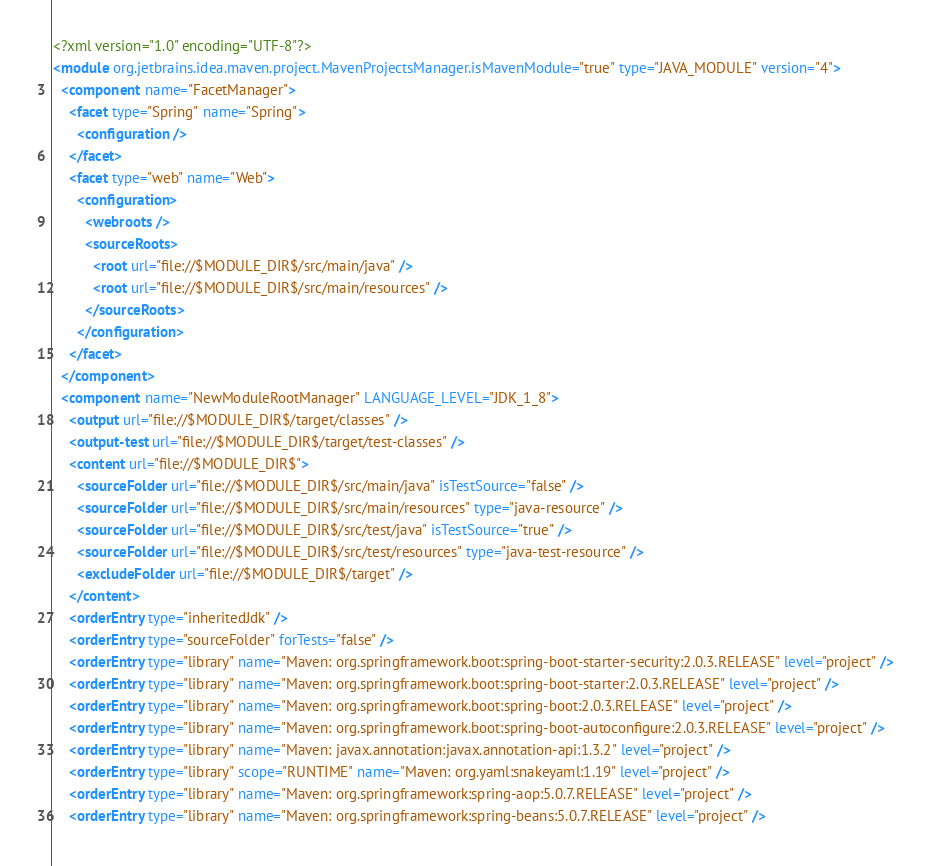Convert code to text. <code><loc_0><loc_0><loc_500><loc_500><_XML_><?xml version="1.0" encoding="UTF-8"?>
<module org.jetbrains.idea.maven.project.MavenProjectsManager.isMavenModule="true" type="JAVA_MODULE" version="4">
  <component name="FacetManager">
    <facet type="Spring" name="Spring">
      <configuration />
    </facet>
    <facet type="web" name="Web">
      <configuration>
        <webroots />
        <sourceRoots>
          <root url="file://$MODULE_DIR$/src/main/java" />
          <root url="file://$MODULE_DIR$/src/main/resources" />
        </sourceRoots>
      </configuration>
    </facet>
  </component>
  <component name="NewModuleRootManager" LANGUAGE_LEVEL="JDK_1_8">
    <output url="file://$MODULE_DIR$/target/classes" />
    <output-test url="file://$MODULE_DIR$/target/test-classes" />
    <content url="file://$MODULE_DIR$">
      <sourceFolder url="file://$MODULE_DIR$/src/main/java" isTestSource="false" />
      <sourceFolder url="file://$MODULE_DIR$/src/main/resources" type="java-resource" />
      <sourceFolder url="file://$MODULE_DIR$/src/test/java" isTestSource="true" />
      <sourceFolder url="file://$MODULE_DIR$/src/test/resources" type="java-test-resource" />
      <excludeFolder url="file://$MODULE_DIR$/target" />
    </content>
    <orderEntry type="inheritedJdk" />
    <orderEntry type="sourceFolder" forTests="false" />
    <orderEntry type="library" name="Maven: org.springframework.boot:spring-boot-starter-security:2.0.3.RELEASE" level="project" />
    <orderEntry type="library" name="Maven: org.springframework.boot:spring-boot-starter:2.0.3.RELEASE" level="project" />
    <orderEntry type="library" name="Maven: org.springframework.boot:spring-boot:2.0.3.RELEASE" level="project" />
    <orderEntry type="library" name="Maven: org.springframework.boot:spring-boot-autoconfigure:2.0.3.RELEASE" level="project" />
    <orderEntry type="library" name="Maven: javax.annotation:javax.annotation-api:1.3.2" level="project" />
    <orderEntry type="library" scope="RUNTIME" name="Maven: org.yaml:snakeyaml:1.19" level="project" />
    <orderEntry type="library" name="Maven: org.springframework:spring-aop:5.0.7.RELEASE" level="project" />
    <orderEntry type="library" name="Maven: org.springframework:spring-beans:5.0.7.RELEASE" level="project" /></code> 